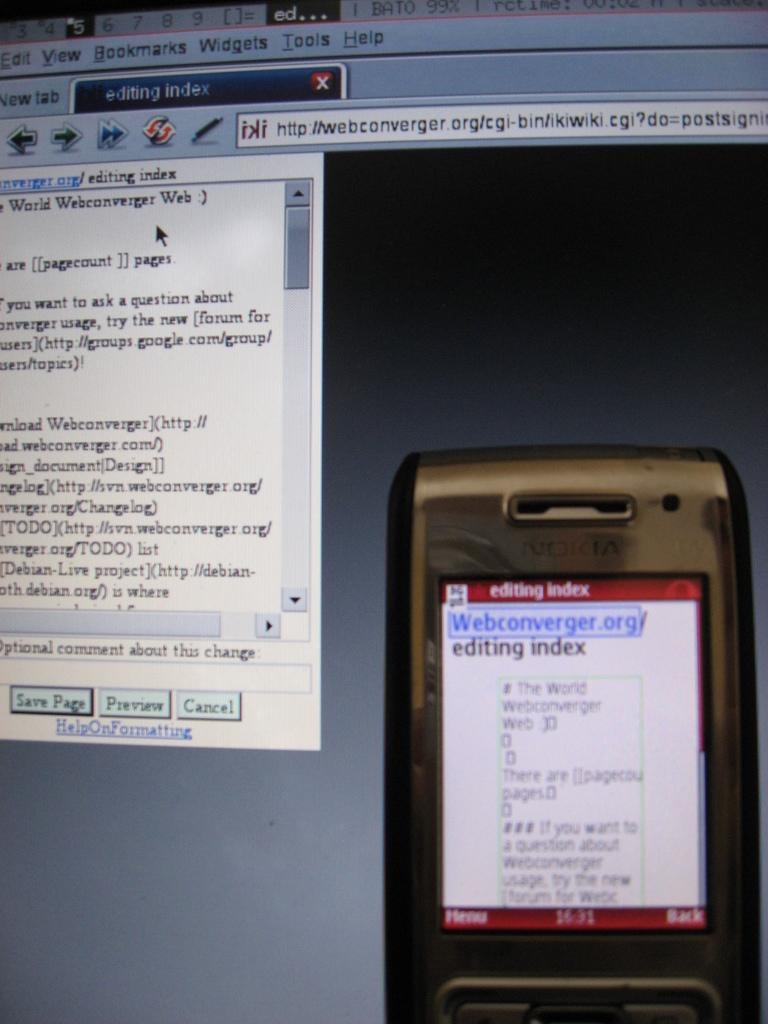<image>
Offer a succinct explanation of the picture presented. A computer screen and a phone with Editing Index written on it. 